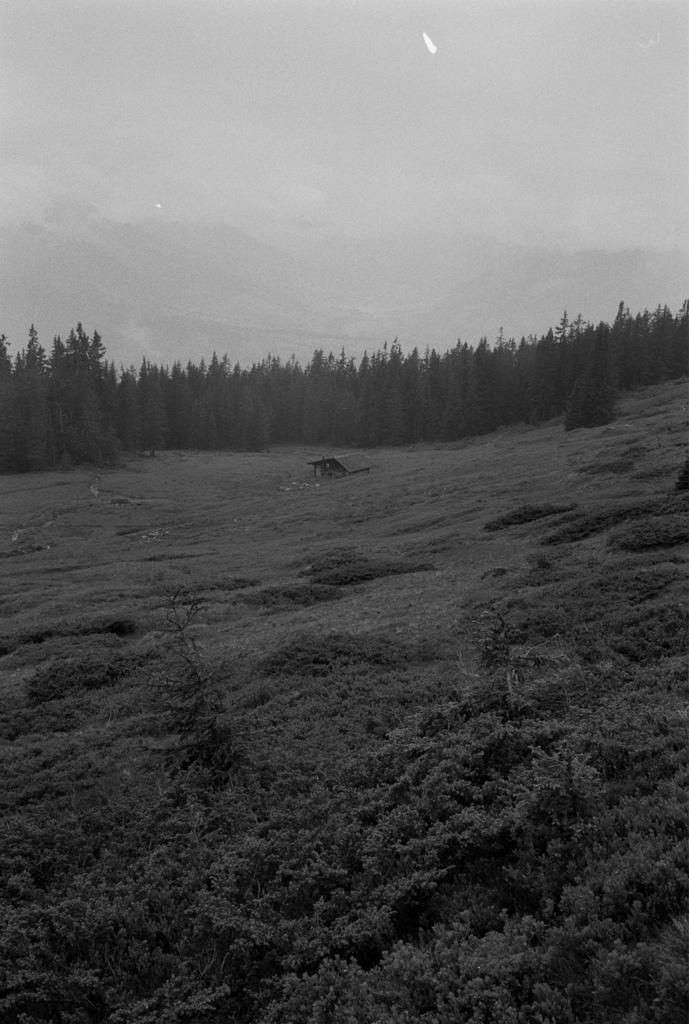Can you describe this image briefly? In this image we can see the plants and shed on the ground. In the background, we can see the trees and the sky. 